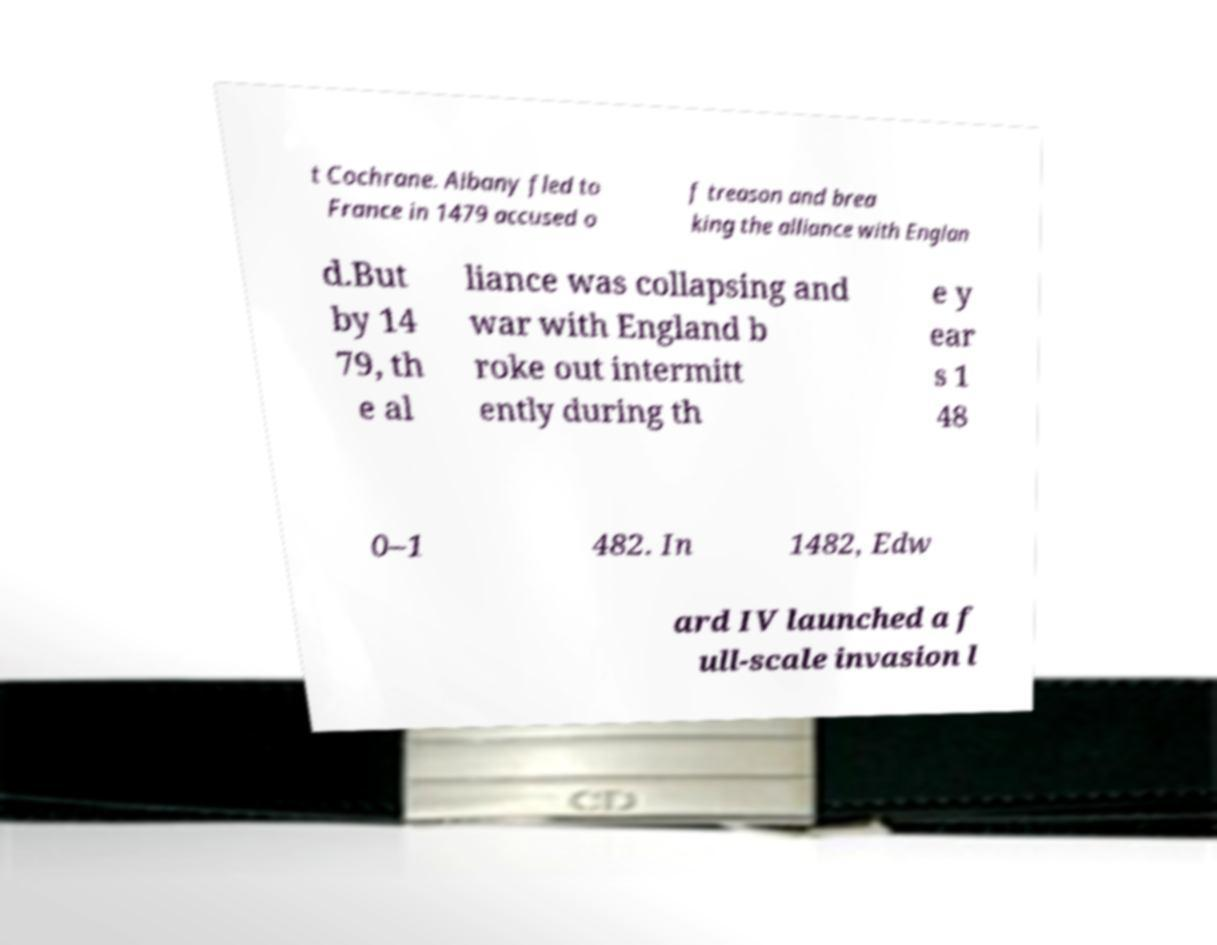Please identify and transcribe the text found in this image. t Cochrane. Albany fled to France in 1479 accused o f treason and brea king the alliance with Englan d.But by 14 79, th e al liance was collapsing and war with England b roke out intermitt ently during th e y ear s 1 48 0–1 482. In 1482, Edw ard IV launched a f ull-scale invasion l 